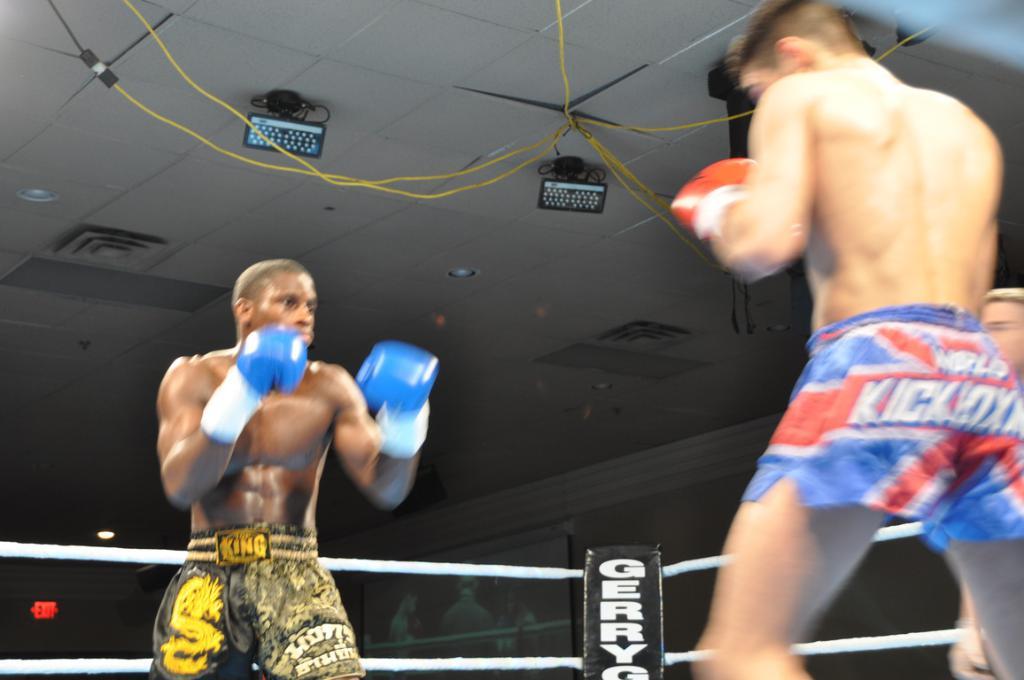Who is the fighter representing?
Your response must be concise. Unanswerable. 